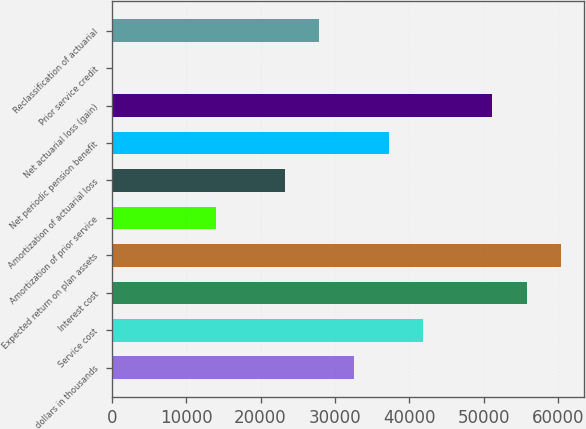<chart> <loc_0><loc_0><loc_500><loc_500><bar_chart><fcel>dollars in thousands<fcel>Service cost<fcel>Interest cost<fcel>Expected return on plan assets<fcel>Amortization of prior service<fcel>Amortization of actuarial loss<fcel>Net periodic pension benefit<fcel>Net actuarial loss (gain)<fcel>Prior service credit<fcel>Reclassification of actuarial<nl><fcel>32554.3<fcel>41854.7<fcel>55805.4<fcel>60455.7<fcel>13953.4<fcel>23253.8<fcel>37204.5<fcel>51155.2<fcel>2.66<fcel>27904<nl></chart> 